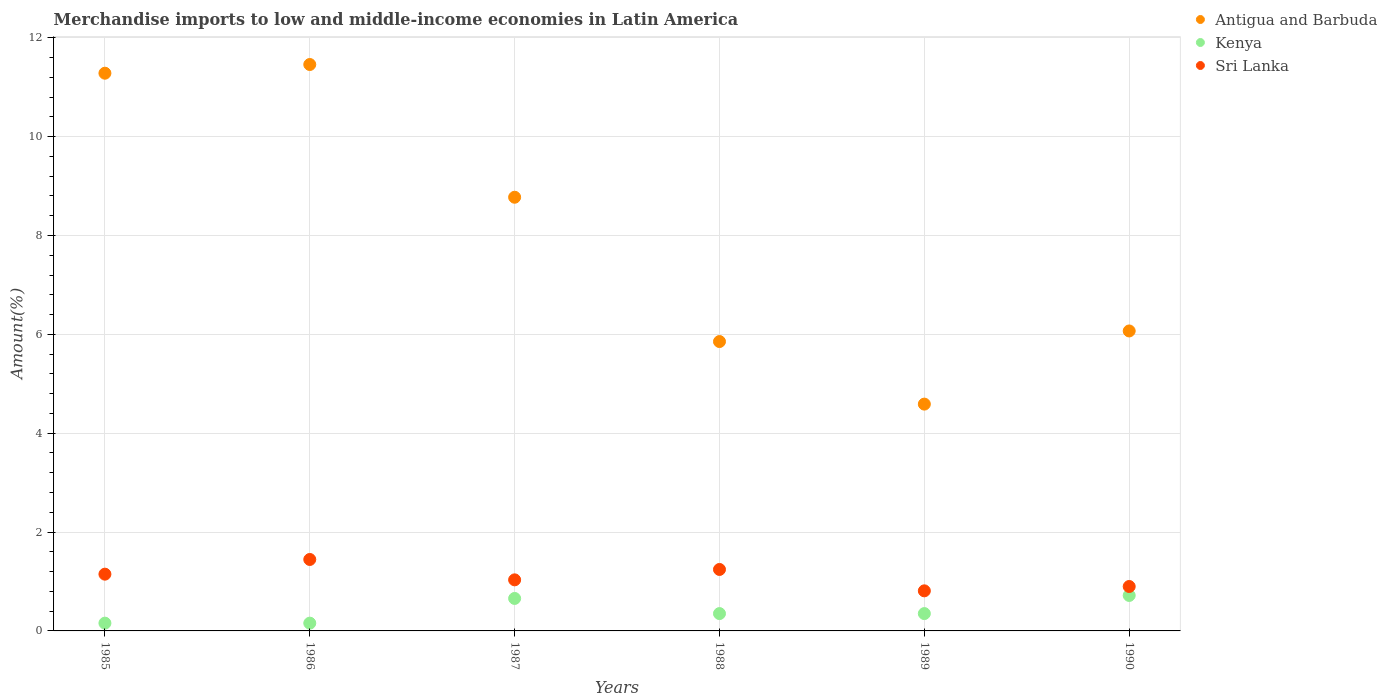How many different coloured dotlines are there?
Offer a very short reply. 3. What is the percentage of amount earned from merchandise imports in Sri Lanka in 1987?
Provide a short and direct response. 1.03. Across all years, what is the maximum percentage of amount earned from merchandise imports in Antigua and Barbuda?
Your response must be concise. 11.46. Across all years, what is the minimum percentage of amount earned from merchandise imports in Kenya?
Offer a terse response. 0.16. In which year was the percentage of amount earned from merchandise imports in Antigua and Barbuda minimum?
Your answer should be compact. 1989. What is the total percentage of amount earned from merchandise imports in Kenya in the graph?
Provide a succinct answer. 2.39. What is the difference between the percentage of amount earned from merchandise imports in Sri Lanka in 1985 and that in 1990?
Make the answer very short. 0.25. What is the difference between the percentage of amount earned from merchandise imports in Kenya in 1988 and the percentage of amount earned from merchandise imports in Antigua and Barbuda in 1989?
Provide a short and direct response. -4.24. What is the average percentage of amount earned from merchandise imports in Kenya per year?
Make the answer very short. 0.4. In the year 1990, what is the difference between the percentage of amount earned from merchandise imports in Antigua and Barbuda and percentage of amount earned from merchandise imports in Sri Lanka?
Your response must be concise. 5.17. What is the ratio of the percentage of amount earned from merchandise imports in Antigua and Barbuda in 1985 to that in 1990?
Offer a terse response. 1.86. Is the percentage of amount earned from merchandise imports in Kenya in 1986 less than that in 1989?
Keep it short and to the point. Yes. Is the difference between the percentage of amount earned from merchandise imports in Antigua and Barbuda in 1988 and 1989 greater than the difference between the percentage of amount earned from merchandise imports in Sri Lanka in 1988 and 1989?
Keep it short and to the point. Yes. What is the difference between the highest and the second highest percentage of amount earned from merchandise imports in Sri Lanka?
Provide a short and direct response. 0.2. What is the difference between the highest and the lowest percentage of amount earned from merchandise imports in Kenya?
Offer a terse response. 0.56. In how many years, is the percentage of amount earned from merchandise imports in Kenya greater than the average percentage of amount earned from merchandise imports in Kenya taken over all years?
Keep it short and to the point. 2. Is it the case that in every year, the sum of the percentage of amount earned from merchandise imports in Antigua and Barbuda and percentage of amount earned from merchandise imports in Kenya  is greater than the percentage of amount earned from merchandise imports in Sri Lanka?
Your answer should be very brief. Yes. Does the percentage of amount earned from merchandise imports in Kenya monotonically increase over the years?
Keep it short and to the point. No. Is the percentage of amount earned from merchandise imports in Kenya strictly greater than the percentage of amount earned from merchandise imports in Sri Lanka over the years?
Your answer should be very brief. No. How many dotlines are there?
Offer a very short reply. 3. Does the graph contain grids?
Your answer should be compact. Yes. What is the title of the graph?
Your answer should be compact. Merchandise imports to low and middle-income economies in Latin America. What is the label or title of the X-axis?
Provide a short and direct response. Years. What is the label or title of the Y-axis?
Offer a very short reply. Amount(%). What is the Amount(%) in Antigua and Barbuda in 1985?
Your answer should be very brief. 11.28. What is the Amount(%) in Kenya in 1985?
Your response must be concise. 0.16. What is the Amount(%) in Sri Lanka in 1985?
Give a very brief answer. 1.15. What is the Amount(%) of Antigua and Barbuda in 1986?
Ensure brevity in your answer.  11.46. What is the Amount(%) in Kenya in 1986?
Offer a very short reply. 0.16. What is the Amount(%) in Sri Lanka in 1986?
Provide a short and direct response. 1.45. What is the Amount(%) in Antigua and Barbuda in 1987?
Offer a terse response. 8.77. What is the Amount(%) in Kenya in 1987?
Give a very brief answer. 0.66. What is the Amount(%) in Sri Lanka in 1987?
Provide a succinct answer. 1.03. What is the Amount(%) of Antigua and Barbuda in 1988?
Your response must be concise. 5.86. What is the Amount(%) in Kenya in 1988?
Give a very brief answer. 0.35. What is the Amount(%) in Sri Lanka in 1988?
Your response must be concise. 1.24. What is the Amount(%) of Antigua and Barbuda in 1989?
Provide a succinct answer. 4.59. What is the Amount(%) of Kenya in 1989?
Your answer should be very brief. 0.35. What is the Amount(%) of Sri Lanka in 1989?
Provide a short and direct response. 0.81. What is the Amount(%) of Antigua and Barbuda in 1990?
Your answer should be very brief. 6.07. What is the Amount(%) of Kenya in 1990?
Provide a short and direct response. 0.72. What is the Amount(%) in Sri Lanka in 1990?
Your response must be concise. 0.9. Across all years, what is the maximum Amount(%) of Antigua and Barbuda?
Ensure brevity in your answer.  11.46. Across all years, what is the maximum Amount(%) of Kenya?
Your answer should be very brief. 0.72. Across all years, what is the maximum Amount(%) of Sri Lanka?
Offer a terse response. 1.45. Across all years, what is the minimum Amount(%) in Antigua and Barbuda?
Ensure brevity in your answer.  4.59. Across all years, what is the minimum Amount(%) of Kenya?
Give a very brief answer. 0.16. Across all years, what is the minimum Amount(%) of Sri Lanka?
Your answer should be compact. 0.81. What is the total Amount(%) of Antigua and Barbuda in the graph?
Make the answer very short. 48.03. What is the total Amount(%) in Kenya in the graph?
Keep it short and to the point. 2.39. What is the total Amount(%) of Sri Lanka in the graph?
Keep it short and to the point. 6.58. What is the difference between the Amount(%) in Antigua and Barbuda in 1985 and that in 1986?
Offer a terse response. -0.18. What is the difference between the Amount(%) in Kenya in 1985 and that in 1986?
Keep it short and to the point. 0. What is the difference between the Amount(%) in Sri Lanka in 1985 and that in 1986?
Offer a very short reply. -0.3. What is the difference between the Amount(%) of Antigua and Barbuda in 1985 and that in 1987?
Your answer should be very brief. 2.51. What is the difference between the Amount(%) in Kenya in 1985 and that in 1987?
Give a very brief answer. -0.5. What is the difference between the Amount(%) in Sri Lanka in 1985 and that in 1987?
Your answer should be very brief. 0.12. What is the difference between the Amount(%) in Antigua and Barbuda in 1985 and that in 1988?
Make the answer very short. 5.43. What is the difference between the Amount(%) of Kenya in 1985 and that in 1988?
Keep it short and to the point. -0.19. What is the difference between the Amount(%) of Sri Lanka in 1985 and that in 1988?
Your answer should be very brief. -0.1. What is the difference between the Amount(%) in Antigua and Barbuda in 1985 and that in 1989?
Offer a very short reply. 6.7. What is the difference between the Amount(%) in Kenya in 1985 and that in 1989?
Keep it short and to the point. -0.19. What is the difference between the Amount(%) in Sri Lanka in 1985 and that in 1989?
Provide a succinct answer. 0.34. What is the difference between the Amount(%) of Antigua and Barbuda in 1985 and that in 1990?
Make the answer very short. 5.22. What is the difference between the Amount(%) of Kenya in 1985 and that in 1990?
Provide a succinct answer. -0.56. What is the difference between the Amount(%) of Sri Lanka in 1985 and that in 1990?
Make the answer very short. 0.25. What is the difference between the Amount(%) of Antigua and Barbuda in 1986 and that in 1987?
Make the answer very short. 2.69. What is the difference between the Amount(%) in Kenya in 1986 and that in 1987?
Provide a short and direct response. -0.5. What is the difference between the Amount(%) of Sri Lanka in 1986 and that in 1987?
Keep it short and to the point. 0.41. What is the difference between the Amount(%) of Antigua and Barbuda in 1986 and that in 1988?
Provide a short and direct response. 5.61. What is the difference between the Amount(%) of Kenya in 1986 and that in 1988?
Your answer should be very brief. -0.19. What is the difference between the Amount(%) in Sri Lanka in 1986 and that in 1988?
Provide a short and direct response. 0.2. What is the difference between the Amount(%) in Antigua and Barbuda in 1986 and that in 1989?
Offer a terse response. 6.87. What is the difference between the Amount(%) of Kenya in 1986 and that in 1989?
Provide a short and direct response. -0.19. What is the difference between the Amount(%) in Sri Lanka in 1986 and that in 1989?
Offer a terse response. 0.63. What is the difference between the Amount(%) in Antigua and Barbuda in 1986 and that in 1990?
Your response must be concise. 5.39. What is the difference between the Amount(%) in Kenya in 1986 and that in 1990?
Make the answer very short. -0.56. What is the difference between the Amount(%) of Sri Lanka in 1986 and that in 1990?
Give a very brief answer. 0.55. What is the difference between the Amount(%) in Antigua and Barbuda in 1987 and that in 1988?
Your answer should be compact. 2.92. What is the difference between the Amount(%) in Kenya in 1987 and that in 1988?
Provide a succinct answer. 0.31. What is the difference between the Amount(%) of Sri Lanka in 1987 and that in 1988?
Give a very brief answer. -0.21. What is the difference between the Amount(%) in Antigua and Barbuda in 1987 and that in 1989?
Provide a succinct answer. 4.19. What is the difference between the Amount(%) in Kenya in 1987 and that in 1989?
Your response must be concise. 0.31. What is the difference between the Amount(%) of Sri Lanka in 1987 and that in 1989?
Your answer should be very brief. 0.22. What is the difference between the Amount(%) in Antigua and Barbuda in 1987 and that in 1990?
Your answer should be compact. 2.71. What is the difference between the Amount(%) of Kenya in 1987 and that in 1990?
Provide a succinct answer. -0.06. What is the difference between the Amount(%) in Sri Lanka in 1987 and that in 1990?
Offer a terse response. 0.13. What is the difference between the Amount(%) of Antigua and Barbuda in 1988 and that in 1989?
Make the answer very short. 1.27. What is the difference between the Amount(%) of Sri Lanka in 1988 and that in 1989?
Your answer should be compact. 0.43. What is the difference between the Amount(%) of Antigua and Barbuda in 1988 and that in 1990?
Your response must be concise. -0.21. What is the difference between the Amount(%) in Kenya in 1988 and that in 1990?
Make the answer very short. -0.37. What is the difference between the Amount(%) of Sri Lanka in 1988 and that in 1990?
Provide a short and direct response. 0.34. What is the difference between the Amount(%) in Antigua and Barbuda in 1989 and that in 1990?
Provide a short and direct response. -1.48. What is the difference between the Amount(%) of Kenya in 1989 and that in 1990?
Your answer should be compact. -0.37. What is the difference between the Amount(%) of Sri Lanka in 1989 and that in 1990?
Make the answer very short. -0.09. What is the difference between the Amount(%) of Antigua and Barbuda in 1985 and the Amount(%) of Kenya in 1986?
Your answer should be compact. 11.13. What is the difference between the Amount(%) in Antigua and Barbuda in 1985 and the Amount(%) in Sri Lanka in 1986?
Give a very brief answer. 9.84. What is the difference between the Amount(%) in Kenya in 1985 and the Amount(%) in Sri Lanka in 1986?
Your answer should be compact. -1.29. What is the difference between the Amount(%) in Antigua and Barbuda in 1985 and the Amount(%) in Kenya in 1987?
Your response must be concise. 10.63. What is the difference between the Amount(%) in Antigua and Barbuda in 1985 and the Amount(%) in Sri Lanka in 1987?
Your answer should be compact. 10.25. What is the difference between the Amount(%) of Kenya in 1985 and the Amount(%) of Sri Lanka in 1987?
Give a very brief answer. -0.88. What is the difference between the Amount(%) of Antigua and Barbuda in 1985 and the Amount(%) of Kenya in 1988?
Ensure brevity in your answer.  10.93. What is the difference between the Amount(%) in Antigua and Barbuda in 1985 and the Amount(%) in Sri Lanka in 1988?
Your response must be concise. 10.04. What is the difference between the Amount(%) of Kenya in 1985 and the Amount(%) of Sri Lanka in 1988?
Offer a very short reply. -1.09. What is the difference between the Amount(%) in Antigua and Barbuda in 1985 and the Amount(%) in Kenya in 1989?
Ensure brevity in your answer.  10.93. What is the difference between the Amount(%) in Antigua and Barbuda in 1985 and the Amount(%) in Sri Lanka in 1989?
Give a very brief answer. 10.47. What is the difference between the Amount(%) of Kenya in 1985 and the Amount(%) of Sri Lanka in 1989?
Provide a short and direct response. -0.65. What is the difference between the Amount(%) of Antigua and Barbuda in 1985 and the Amount(%) of Kenya in 1990?
Make the answer very short. 10.57. What is the difference between the Amount(%) in Antigua and Barbuda in 1985 and the Amount(%) in Sri Lanka in 1990?
Provide a short and direct response. 10.39. What is the difference between the Amount(%) of Kenya in 1985 and the Amount(%) of Sri Lanka in 1990?
Keep it short and to the point. -0.74. What is the difference between the Amount(%) in Antigua and Barbuda in 1986 and the Amount(%) in Kenya in 1987?
Offer a very short reply. 10.8. What is the difference between the Amount(%) of Antigua and Barbuda in 1986 and the Amount(%) of Sri Lanka in 1987?
Ensure brevity in your answer.  10.43. What is the difference between the Amount(%) in Kenya in 1986 and the Amount(%) in Sri Lanka in 1987?
Ensure brevity in your answer.  -0.88. What is the difference between the Amount(%) in Antigua and Barbuda in 1986 and the Amount(%) in Kenya in 1988?
Ensure brevity in your answer.  11.11. What is the difference between the Amount(%) in Antigua and Barbuda in 1986 and the Amount(%) in Sri Lanka in 1988?
Offer a very short reply. 10.22. What is the difference between the Amount(%) of Kenya in 1986 and the Amount(%) of Sri Lanka in 1988?
Offer a terse response. -1.09. What is the difference between the Amount(%) of Antigua and Barbuda in 1986 and the Amount(%) of Kenya in 1989?
Your answer should be very brief. 11.11. What is the difference between the Amount(%) of Antigua and Barbuda in 1986 and the Amount(%) of Sri Lanka in 1989?
Keep it short and to the point. 10.65. What is the difference between the Amount(%) of Kenya in 1986 and the Amount(%) of Sri Lanka in 1989?
Your answer should be compact. -0.65. What is the difference between the Amount(%) of Antigua and Barbuda in 1986 and the Amount(%) of Kenya in 1990?
Offer a very short reply. 10.74. What is the difference between the Amount(%) in Antigua and Barbuda in 1986 and the Amount(%) in Sri Lanka in 1990?
Offer a very short reply. 10.56. What is the difference between the Amount(%) in Kenya in 1986 and the Amount(%) in Sri Lanka in 1990?
Ensure brevity in your answer.  -0.74. What is the difference between the Amount(%) in Antigua and Barbuda in 1987 and the Amount(%) in Kenya in 1988?
Make the answer very short. 8.42. What is the difference between the Amount(%) of Antigua and Barbuda in 1987 and the Amount(%) of Sri Lanka in 1988?
Ensure brevity in your answer.  7.53. What is the difference between the Amount(%) of Kenya in 1987 and the Amount(%) of Sri Lanka in 1988?
Your answer should be compact. -0.59. What is the difference between the Amount(%) in Antigua and Barbuda in 1987 and the Amount(%) in Kenya in 1989?
Ensure brevity in your answer.  8.42. What is the difference between the Amount(%) of Antigua and Barbuda in 1987 and the Amount(%) of Sri Lanka in 1989?
Keep it short and to the point. 7.96. What is the difference between the Amount(%) in Kenya in 1987 and the Amount(%) in Sri Lanka in 1989?
Give a very brief answer. -0.15. What is the difference between the Amount(%) of Antigua and Barbuda in 1987 and the Amount(%) of Kenya in 1990?
Keep it short and to the point. 8.06. What is the difference between the Amount(%) in Antigua and Barbuda in 1987 and the Amount(%) in Sri Lanka in 1990?
Your response must be concise. 7.88. What is the difference between the Amount(%) in Kenya in 1987 and the Amount(%) in Sri Lanka in 1990?
Keep it short and to the point. -0.24. What is the difference between the Amount(%) of Antigua and Barbuda in 1988 and the Amount(%) of Kenya in 1989?
Your answer should be very brief. 5.5. What is the difference between the Amount(%) of Antigua and Barbuda in 1988 and the Amount(%) of Sri Lanka in 1989?
Provide a short and direct response. 5.04. What is the difference between the Amount(%) in Kenya in 1988 and the Amount(%) in Sri Lanka in 1989?
Offer a terse response. -0.46. What is the difference between the Amount(%) in Antigua and Barbuda in 1988 and the Amount(%) in Kenya in 1990?
Offer a very short reply. 5.14. What is the difference between the Amount(%) of Antigua and Barbuda in 1988 and the Amount(%) of Sri Lanka in 1990?
Provide a short and direct response. 4.96. What is the difference between the Amount(%) in Kenya in 1988 and the Amount(%) in Sri Lanka in 1990?
Provide a short and direct response. -0.55. What is the difference between the Amount(%) in Antigua and Barbuda in 1989 and the Amount(%) in Kenya in 1990?
Your response must be concise. 3.87. What is the difference between the Amount(%) in Antigua and Barbuda in 1989 and the Amount(%) in Sri Lanka in 1990?
Your response must be concise. 3.69. What is the difference between the Amount(%) in Kenya in 1989 and the Amount(%) in Sri Lanka in 1990?
Your answer should be very brief. -0.55. What is the average Amount(%) in Antigua and Barbuda per year?
Your response must be concise. 8.01. What is the average Amount(%) of Kenya per year?
Offer a very short reply. 0.4. What is the average Amount(%) in Sri Lanka per year?
Your answer should be compact. 1.1. In the year 1985, what is the difference between the Amount(%) of Antigua and Barbuda and Amount(%) of Kenya?
Provide a short and direct response. 11.13. In the year 1985, what is the difference between the Amount(%) of Antigua and Barbuda and Amount(%) of Sri Lanka?
Ensure brevity in your answer.  10.14. In the year 1985, what is the difference between the Amount(%) in Kenya and Amount(%) in Sri Lanka?
Offer a very short reply. -0.99. In the year 1986, what is the difference between the Amount(%) of Antigua and Barbuda and Amount(%) of Kenya?
Offer a terse response. 11.3. In the year 1986, what is the difference between the Amount(%) in Antigua and Barbuda and Amount(%) in Sri Lanka?
Give a very brief answer. 10.01. In the year 1986, what is the difference between the Amount(%) in Kenya and Amount(%) in Sri Lanka?
Keep it short and to the point. -1.29. In the year 1987, what is the difference between the Amount(%) of Antigua and Barbuda and Amount(%) of Kenya?
Your response must be concise. 8.12. In the year 1987, what is the difference between the Amount(%) of Antigua and Barbuda and Amount(%) of Sri Lanka?
Keep it short and to the point. 7.74. In the year 1987, what is the difference between the Amount(%) of Kenya and Amount(%) of Sri Lanka?
Offer a very short reply. -0.38. In the year 1988, what is the difference between the Amount(%) of Antigua and Barbuda and Amount(%) of Kenya?
Offer a very short reply. 5.5. In the year 1988, what is the difference between the Amount(%) of Antigua and Barbuda and Amount(%) of Sri Lanka?
Offer a terse response. 4.61. In the year 1988, what is the difference between the Amount(%) of Kenya and Amount(%) of Sri Lanka?
Provide a succinct answer. -0.89. In the year 1989, what is the difference between the Amount(%) of Antigua and Barbuda and Amount(%) of Kenya?
Ensure brevity in your answer.  4.24. In the year 1989, what is the difference between the Amount(%) of Antigua and Barbuda and Amount(%) of Sri Lanka?
Keep it short and to the point. 3.78. In the year 1989, what is the difference between the Amount(%) in Kenya and Amount(%) in Sri Lanka?
Make the answer very short. -0.46. In the year 1990, what is the difference between the Amount(%) in Antigua and Barbuda and Amount(%) in Kenya?
Ensure brevity in your answer.  5.35. In the year 1990, what is the difference between the Amount(%) of Antigua and Barbuda and Amount(%) of Sri Lanka?
Your answer should be very brief. 5.17. In the year 1990, what is the difference between the Amount(%) of Kenya and Amount(%) of Sri Lanka?
Provide a succinct answer. -0.18. What is the ratio of the Amount(%) of Antigua and Barbuda in 1985 to that in 1986?
Offer a terse response. 0.98. What is the ratio of the Amount(%) of Kenya in 1985 to that in 1986?
Keep it short and to the point. 1. What is the ratio of the Amount(%) of Sri Lanka in 1985 to that in 1986?
Provide a short and direct response. 0.79. What is the ratio of the Amount(%) of Antigua and Barbuda in 1985 to that in 1987?
Offer a very short reply. 1.29. What is the ratio of the Amount(%) of Kenya in 1985 to that in 1987?
Your response must be concise. 0.24. What is the ratio of the Amount(%) in Sri Lanka in 1985 to that in 1987?
Your response must be concise. 1.11. What is the ratio of the Amount(%) of Antigua and Barbuda in 1985 to that in 1988?
Your response must be concise. 1.93. What is the ratio of the Amount(%) in Kenya in 1985 to that in 1988?
Provide a short and direct response. 0.45. What is the ratio of the Amount(%) in Sri Lanka in 1985 to that in 1988?
Keep it short and to the point. 0.92. What is the ratio of the Amount(%) in Antigua and Barbuda in 1985 to that in 1989?
Keep it short and to the point. 2.46. What is the ratio of the Amount(%) of Kenya in 1985 to that in 1989?
Make the answer very short. 0.45. What is the ratio of the Amount(%) of Sri Lanka in 1985 to that in 1989?
Provide a short and direct response. 1.42. What is the ratio of the Amount(%) of Antigua and Barbuda in 1985 to that in 1990?
Your answer should be very brief. 1.86. What is the ratio of the Amount(%) in Kenya in 1985 to that in 1990?
Provide a short and direct response. 0.22. What is the ratio of the Amount(%) in Sri Lanka in 1985 to that in 1990?
Your response must be concise. 1.28. What is the ratio of the Amount(%) in Antigua and Barbuda in 1986 to that in 1987?
Keep it short and to the point. 1.31. What is the ratio of the Amount(%) in Kenya in 1986 to that in 1987?
Keep it short and to the point. 0.24. What is the ratio of the Amount(%) in Sri Lanka in 1986 to that in 1987?
Keep it short and to the point. 1.4. What is the ratio of the Amount(%) of Antigua and Barbuda in 1986 to that in 1988?
Keep it short and to the point. 1.96. What is the ratio of the Amount(%) in Kenya in 1986 to that in 1988?
Your answer should be very brief. 0.45. What is the ratio of the Amount(%) of Sri Lanka in 1986 to that in 1988?
Give a very brief answer. 1.16. What is the ratio of the Amount(%) in Antigua and Barbuda in 1986 to that in 1989?
Make the answer very short. 2.5. What is the ratio of the Amount(%) in Kenya in 1986 to that in 1989?
Provide a succinct answer. 0.45. What is the ratio of the Amount(%) of Sri Lanka in 1986 to that in 1989?
Your response must be concise. 1.78. What is the ratio of the Amount(%) of Antigua and Barbuda in 1986 to that in 1990?
Provide a short and direct response. 1.89. What is the ratio of the Amount(%) in Kenya in 1986 to that in 1990?
Provide a short and direct response. 0.22. What is the ratio of the Amount(%) in Sri Lanka in 1986 to that in 1990?
Your answer should be compact. 1.61. What is the ratio of the Amount(%) of Antigua and Barbuda in 1987 to that in 1988?
Keep it short and to the point. 1.5. What is the ratio of the Amount(%) of Kenya in 1987 to that in 1988?
Provide a succinct answer. 1.87. What is the ratio of the Amount(%) of Sri Lanka in 1987 to that in 1988?
Provide a succinct answer. 0.83. What is the ratio of the Amount(%) of Antigua and Barbuda in 1987 to that in 1989?
Offer a terse response. 1.91. What is the ratio of the Amount(%) of Kenya in 1987 to that in 1989?
Offer a terse response. 1.87. What is the ratio of the Amount(%) in Sri Lanka in 1987 to that in 1989?
Give a very brief answer. 1.27. What is the ratio of the Amount(%) of Antigua and Barbuda in 1987 to that in 1990?
Your response must be concise. 1.45. What is the ratio of the Amount(%) in Kenya in 1987 to that in 1990?
Your answer should be very brief. 0.92. What is the ratio of the Amount(%) in Sri Lanka in 1987 to that in 1990?
Ensure brevity in your answer.  1.15. What is the ratio of the Amount(%) in Antigua and Barbuda in 1988 to that in 1989?
Provide a short and direct response. 1.28. What is the ratio of the Amount(%) of Kenya in 1988 to that in 1989?
Your answer should be very brief. 1. What is the ratio of the Amount(%) of Sri Lanka in 1988 to that in 1989?
Your answer should be compact. 1.53. What is the ratio of the Amount(%) of Antigua and Barbuda in 1988 to that in 1990?
Make the answer very short. 0.96. What is the ratio of the Amount(%) in Kenya in 1988 to that in 1990?
Your response must be concise. 0.49. What is the ratio of the Amount(%) of Sri Lanka in 1988 to that in 1990?
Your answer should be compact. 1.38. What is the ratio of the Amount(%) in Antigua and Barbuda in 1989 to that in 1990?
Provide a succinct answer. 0.76. What is the ratio of the Amount(%) of Kenya in 1989 to that in 1990?
Keep it short and to the point. 0.49. What is the ratio of the Amount(%) of Sri Lanka in 1989 to that in 1990?
Make the answer very short. 0.9. What is the difference between the highest and the second highest Amount(%) of Antigua and Barbuda?
Give a very brief answer. 0.18. What is the difference between the highest and the second highest Amount(%) in Kenya?
Ensure brevity in your answer.  0.06. What is the difference between the highest and the second highest Amount(%) in Sri Lanka?
Keep it short and to the point. 0.2. What is the difference between the highest and the lowest Amount(%) of Antigua and Barbuda?
Give a very brief answer. 6.87. What is the difference between the highest and the lowest Amount(%) of Kenya?
Offer a terse response. 0.56. What is the difference between the highest and the lowest Amount(%) of Sri Lanka?
Offer a terse response. 0.63. 